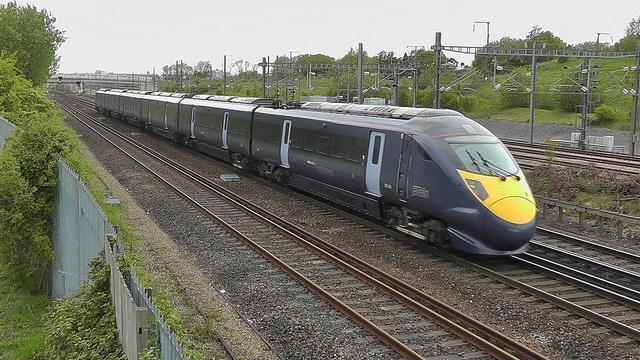How many tracks can be seen?
Give a very brief answer. 3. How many sets of tracks are there?
Give a very brief answer. 3. How many buttons is the man touching?
Give a very brief answer. 0. 